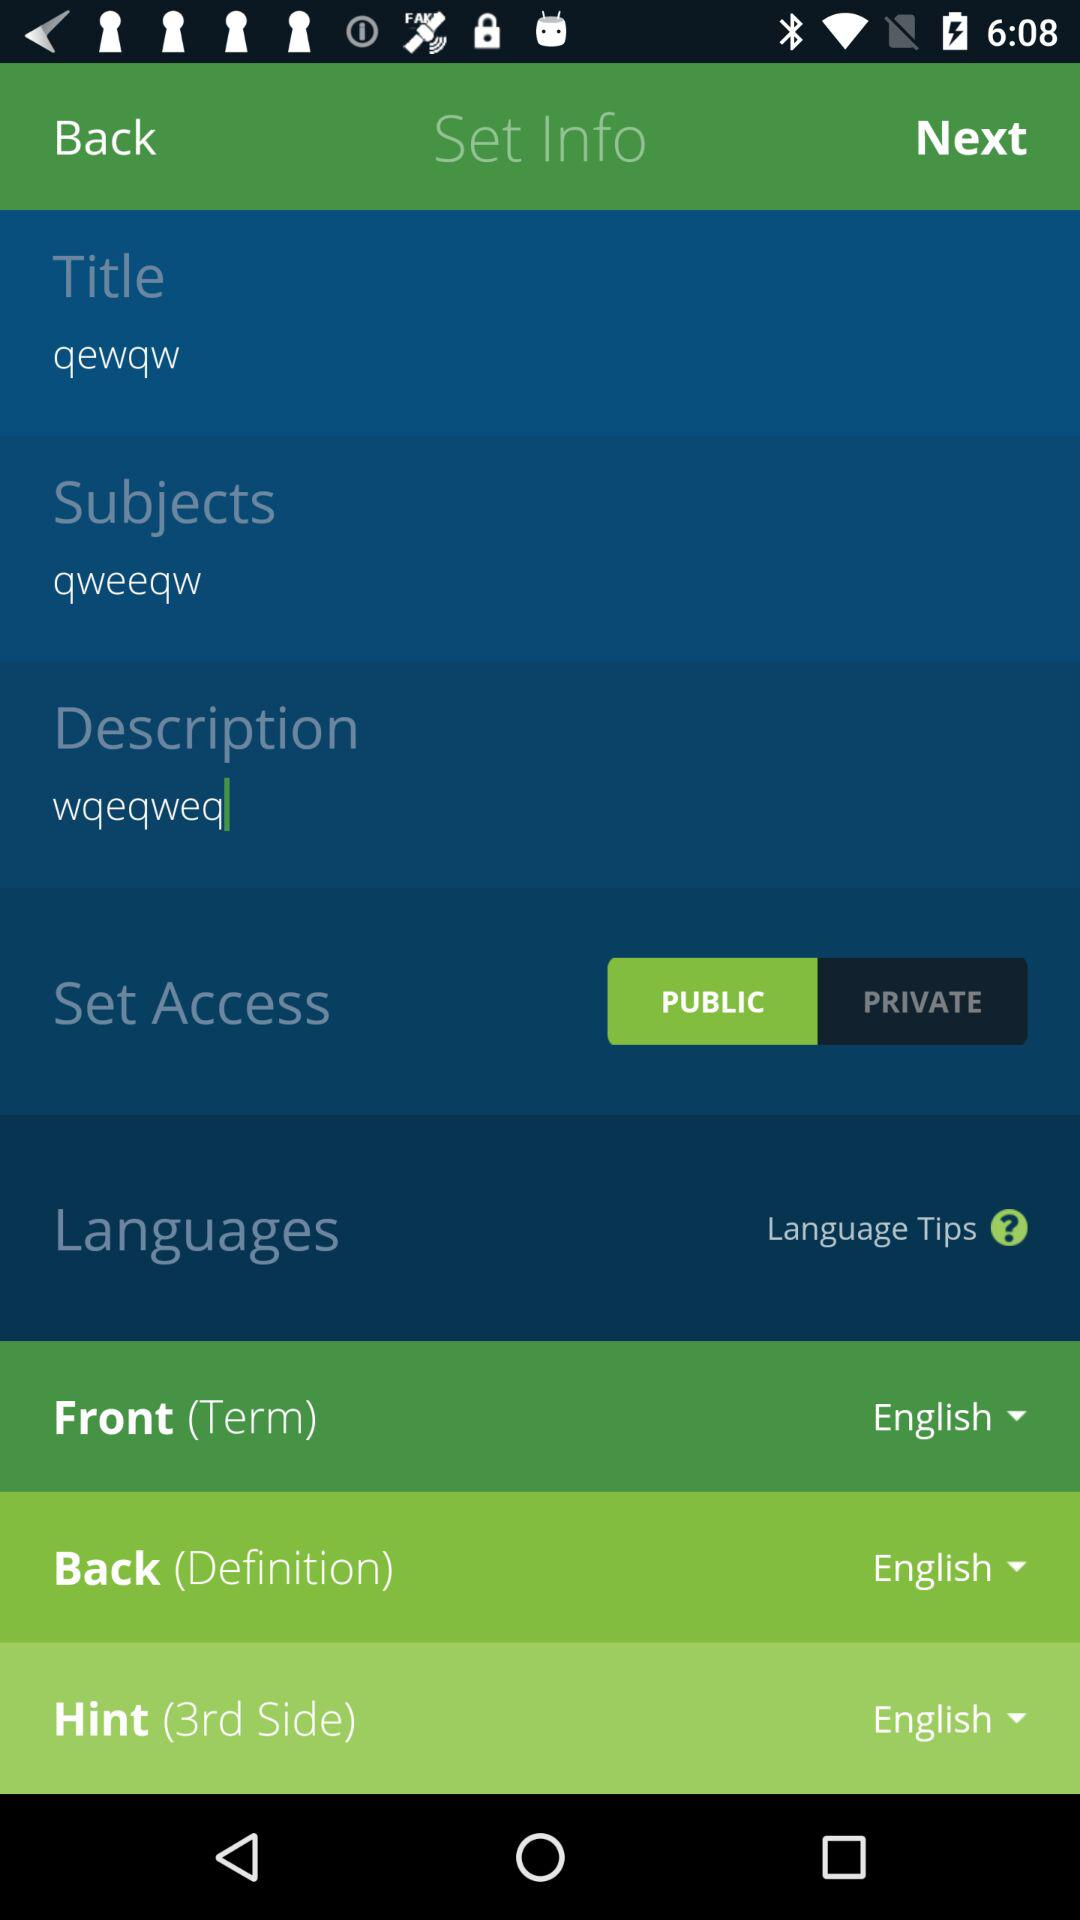What is the selected type of "Set Access"? The selected type of "Set Access" is "PUBLIC". 